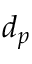<formula> <loc_0><loc_0><loc_500><loc_500>d _ { p }</formula> 